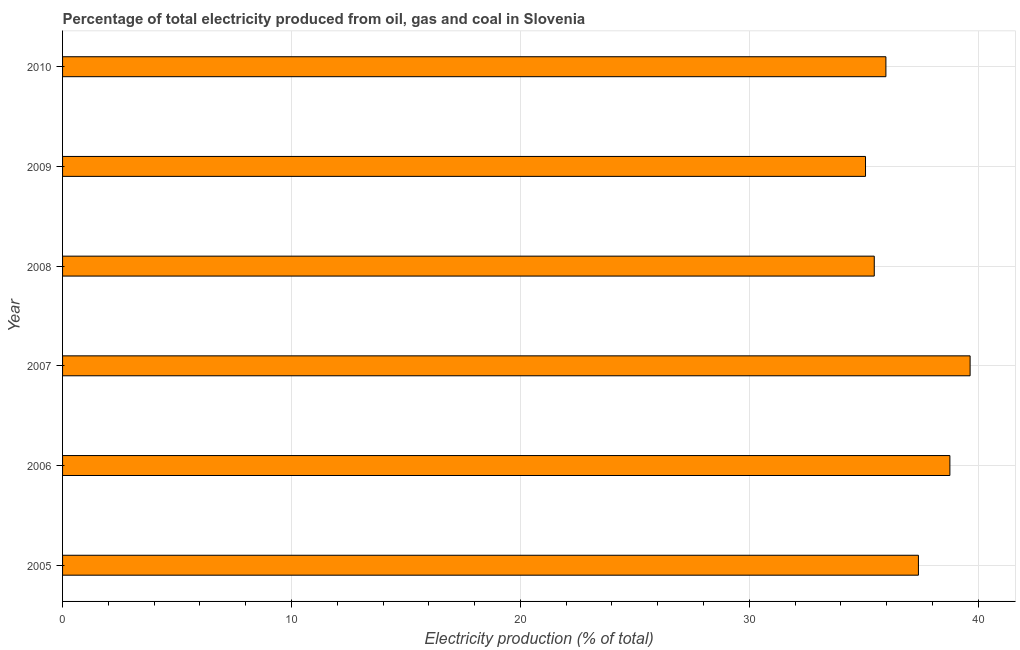What is the title of the graph?
Your answer should be very brief. Percentage of total electricity produced from oil, gas and coal in Slovenia. What is the label or title of the X-axis?
Offer a terse response. Electricity production (% of total). What is the electricity production in 2006?
Offer a very short reply. 38.76. Across all years, what is the maximum electricity production?
Provide a short and direct response. 39.65. Across all years, what is the minimum electricity production?
Your answer should be very brief. 35.08. In which year was the electricity production minimum?
Ensure brevity in your answer.  2009. What is the sum of the electricity production?
Provide a succinct answer. 222.3. What is the difference between the electricity production in 2009 and 2010?
Provide a short and direct response. -0.89. What is the average electricity production per year?
Provide a succinct answer. 37.05. What is the median electricity production?
Offer a terse response. 36.68. In how many years, is the electricity production greater than 6 %?
Offer a terse response. 6. What is the ratio of the electricity production in 2008 to that in 2010?
Make the answer very short. 0.99. Is the electricity production in 2007 less than that in 2010?
Ensure brevity in your answer.  No. Is the difference between the electricity production in 2005 and 2009 greater than the difference between any two years?
Your answer should be compact. No. What is the difference between the highest and the second highest electricity production?
Offer a very short reply. 0.88. What is the difference between the highest and the lowest electricity production?
Keep it short and to the point. 4.57. How many bars are there?
Offer a terse response. 6. Are all the bars in the graph horizontal?
Make the answer very short. Yes. How many years are there in the graph?
Ensure brevity in your answer.  6. What is the Electricity production (% of total) of 2005?
Ensure brevity in your answer.  37.39. What is the Electricity production (% of total) of 2006?
Provide a succinct answer. 38.76. What is the Electricity production (% of total) of 2007?
Offer a very short reply. 39.65. What is the Electricity production (% of total) in 2008?
Your answer should be very brief. 35.46. What is the Electricity production (% of total) of 2009?
Keep it short and to the point. 35.08. What is the Electricity production (% of total) in 2010?
Give a very brief answer. 35.97. What is the difference between the Electricity production (% of total) in 2005 and 2006?
Provide a succinct answer. -1.37. What is the difference between the Electricity production (% of total) in 2005 and 2007?
Provide a succinct answer. -2.26. What is the difference between the Electricity production (% of total) in 2005 and 2008?
Your response must be concise. 1.93. What is the difference between the Electricity production (% of total) in 2005 and 2009?
Your answer should be very brief. 2.31. What is the difference between the Electricity production (% of total) in 2005 and 2010?
Your response must be concise. 1.42. What is the difference between the Electricity production (% of total) in 2006 and 2007?
Ensure brevity in your answer.  -0.88. What is the difference between the Electricity production (% of total) in 2006 and 2008?
Make the answer very short. 3.3. What is the difference between the Electricity production (% of total) in 2006 and 2009?
Offer a terse response. 3.69. What is the difference between the Electricity production (% of total) in 2006 and 2010?
Provide a short and direct response. 2.8. What is the difference between the Electricity production (% of total) in 2007 and 2008?
Offer a very short reply. 4.19. What is the difference between the Electricity production (% of total) in 2007 and 2009?
Provide a succinct answer. 4.57. What is the difference between the Electricity production (% of total) in 2007 and 2010?
Provide a short and direct response. 3.68. What is the difference between the Electricity production (% of total) in 2008 and 2009?
Ensure brevity in your answer.  0.38. What is the difference between the Electricity production (% of total) in 2008 and 2010?
Offer a terse response. -0.51. What is the difference between the Electricity production (% of total) in 2009 and 2010?
Make the answer very short. -0.89. What is the ratio of the Electricity production (% of total) in 2005 to that in 2006?
Offer a terse response. 0.96. What is the ratio of the Electricity production (% of total) in 2005 to that in 2007?
Your response must be concise. 0.94. What is the ratio of the Electricity production (% of total) in 2005 to that in 2008?
Your answer should be compact. 1.05. What is the ratio of the Electricity production (% of total) in 2005 to that in 2009?
Keep it short and to the point. 1.07. What is the ratio of the Electricity production (% of total) in 2005 to that in 2010?
Your answer should be very brief. 1.04. What is the ratio of the Electricity production (% of total) in 2006 to that in 2007?
Provide a short and direct response. 0.98. What is the ratio of the Electricity production (% of total) in 2006 to that in 2008?
Give a very brief answer. 1.09. What is the ratio of the Electricity production (% of total) in 2006 to that in 2009?
Your response must be concise. 1.1. What is the ratio of the Electricity production (% of total) in 2006 to that in 2010?
Offer a terse response. 1.08. What is the ratio of the Electricity production (% of total) in 2007 to that in 2008?
Give a very brief answer. 1.12. What is the ratio of the Electricity production (% of total) in 2007 to that in 2009?
Make the answer very short. 1.13. What is the ratio of the Electricity production (% of total) in 2007 to that in 2010?
Provide a short and direct response. 1.1. What is the ratio of the Electricity production (% of total) in 2008 to that in 2010?
Offer a terse response. 0.99. What is the ratio of the Electricity production (% of total) in 2009 to that in 2010?
Your answer should be very brief. 0.97. 